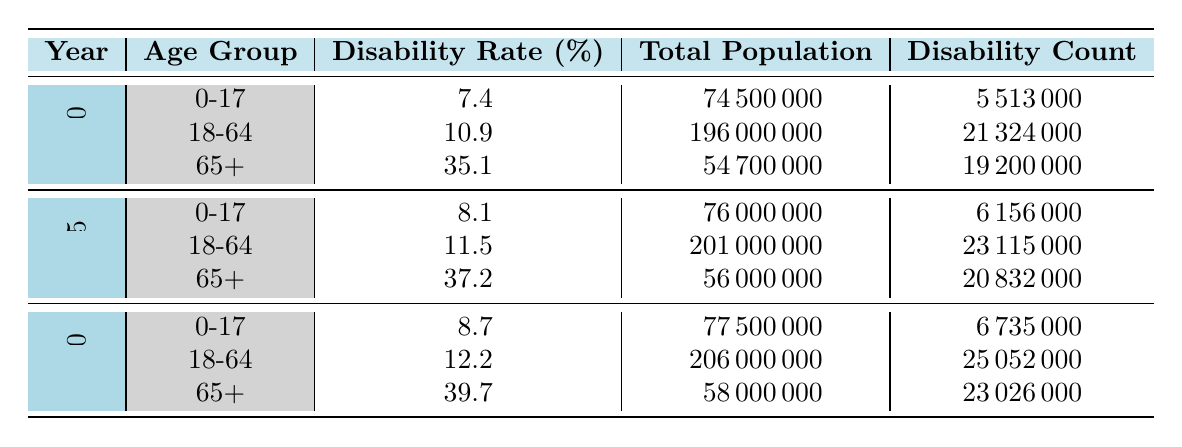What is the disability rate for the age group 18-64 in 2020? The disability rate for the age group 18-64 in the year 2020 can be directly retrieved from the table. It shows that the disability rate is 10.9%.
Answer: 10.9% How many individuals aged 65 and older were reported with disabilities in 2025? The table indicates that in 2025, the disability count for individuals aged 65 and older is 20,832,000. This value can be found in the respective row for the year 2025 and age group 65+.
Answer: 20,832,000 What is the percentage increase in the disability rate for the age group 0-17 from 2020 to 2030? The disability rate for 0-17 in 2020 is 7.4%, and in 2030 it is 8.7%. The percentage increase is calculated as follows: ((8.7 - 7.4) / 7.4) * 100 = 17.57%. This shows the change in disability rate over the 10-year period.
Answer: 17.57% Is the total population for the age group 18-64 greater in 2025 than in 2020? By checking the values in the table, the total population for the age group 18-64 in 2025 is 201,000,000, while in 2020 it is 196,000,000. Since 201,000,000 is greater than 196,000,000, the statement is true.
Answer: Yes What was the total disability count for all age groups combined in 2030? To find the total disability count in 2030, sum the counts for all age groups: 6,735,000 (0-17) + 25,052,000 (18-64) + 23,026,000 (65+) = 54,813,000. This calculation combines the disability counts from the respective rows.
Answer: 54,813,000 Has the disability rate for the 18-64 age group increased from 2020 to 2030? The disability rate for the 18-64 age group in 2020 is 10.9% and in 2030 it is 12.2%. Since 12.2% is greater than 10.9%, the disability rate has indeed increased.
Answer: Yes What is the disability rate for the age group 65 and older in 2025 compared to 2030? The table shows that the disability rate for the age group 65 and older is 37.2% in 2025 and increases to 39.7% in 2030. Thus, the rate is higher in 2030.
Answer: 39.7% in 2030 is higher than 37.2% in 2025 What is the average disability rate for the age group 0-17 across the years listed? The disability rates for the age group 0-17 are 7.4% (2020), 8.1% (2025), and 8.7% (2030). To find the average: (7.4 + 8.1 + 8.7) / 3 = 8.14. This gives an average disability rate for this age group across the three years.
Answer: 8.14% 